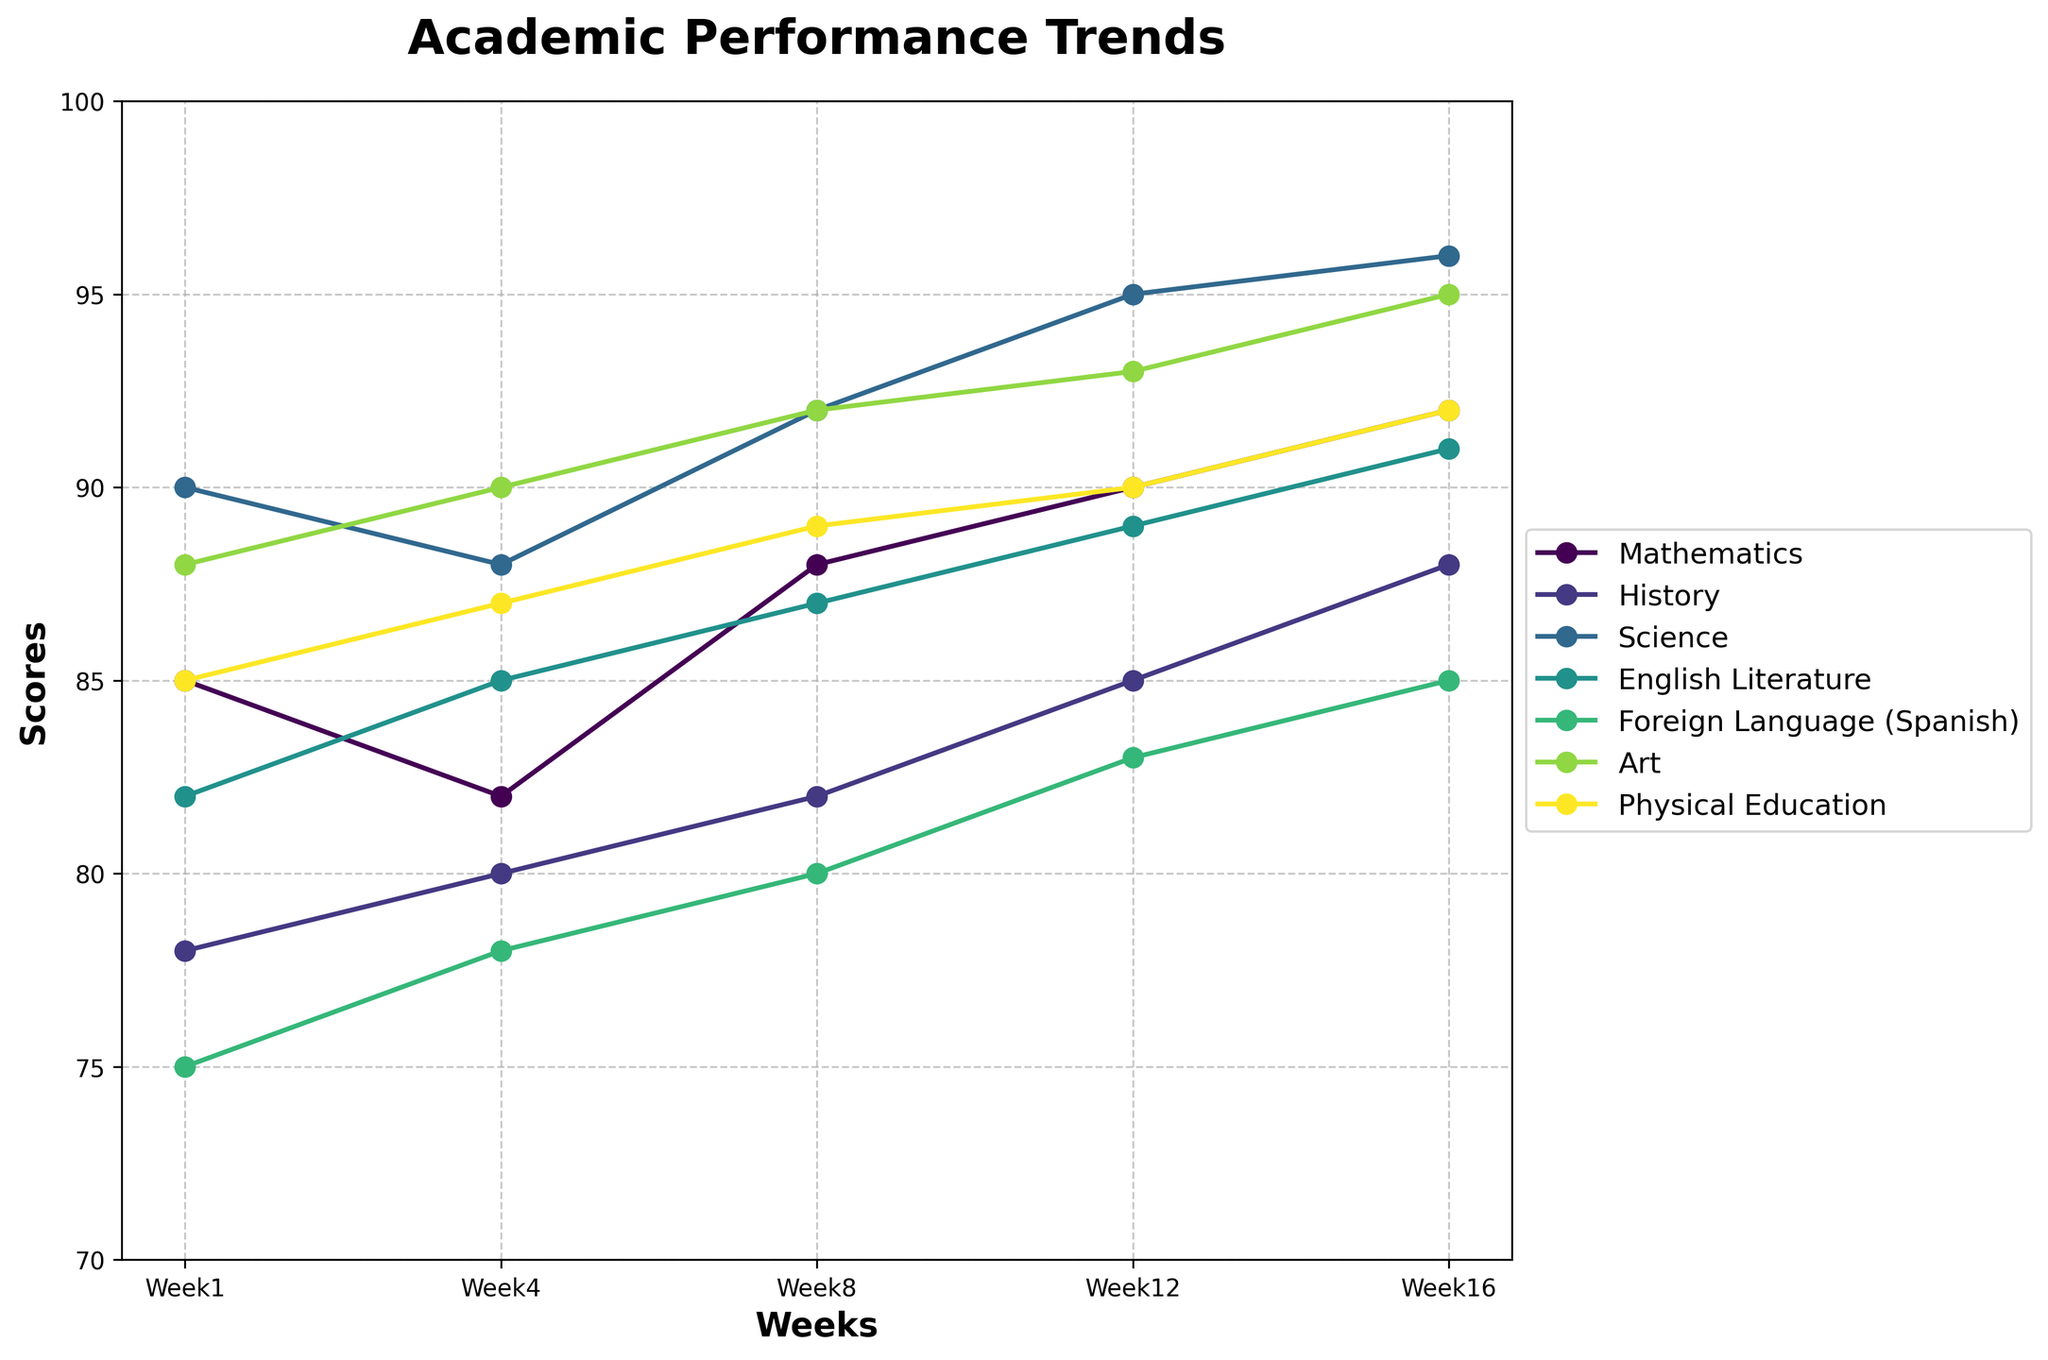What is the title of the plot? The title is found at the top of the plot. It is labeled clearly to describe the data being presented.
Answer: Academic Performance Trends How many subjects are tracked in the plot? By counting the number of distinct lines, each representing a different subject, in the plot, we can determine the number of subjects.
Answer: 7 Which subject had the highest score in Week 16? Look at the scores for each subject in Week 16 and find the highest one. Science has the score of 96, which is the highest compared to other subjects.
Answer: Science How did the score for Mathematics change from Week 1 to Week 16? Look at the values for Mathematics at Week 1 (85) and Week 16 (92). Subtract the Week 1 score from the Week 16 score to find the change: 92 - 85 = 7.
Answer: Increased by 7 Which subjects have scores greater than 90 in Week 12? Look at the scores in Week 12 and identify the subjects with scores above 90. The subjects are Science (95), Art (93), and Physical Education (90).
Answer: Science, Art What is the average score for English Literature across all weeks? Sum the scores for English Literature across Weeks 1, 4, 8, 12, and 16 and divide by the number of weeks: (82 + 85 + 87 + 89 + 91) / 5 = 86.8.
Answer: 86.8 Which subject showed the most improvement over the semester? Calculate the difference in scores from Week 1 to Week 16 for each subject. History improved from 78 to 88, showing the greatest increase of 10 points.
Answer: History Is the score for Physical Education always higher than Foreign Language (Spanish)? Compare the scores for Physical Education and Foreign Language (Spanish) at each week. Physical Education scores are consistently higher (85, 87, 89, 90, 92) compared to Foreign Language (75, 78, 80, 83, 85).
Answer: Yes During which week did English Literature have its highest score, and what was the score? Look at the scores for English Literature and identify the week with the highest score, which is Week 16 with a score of 91.
Answer: Week 16, 91 Which subject had a decrease in scores between Week 1 and Week 4? Compare the scores between Week 1 and Week 4 for each subject. Mathematics and Science both had a decrease: Mathematics (85 to 82) and Science (90 to 88).
Answer: Mathematics and Science 